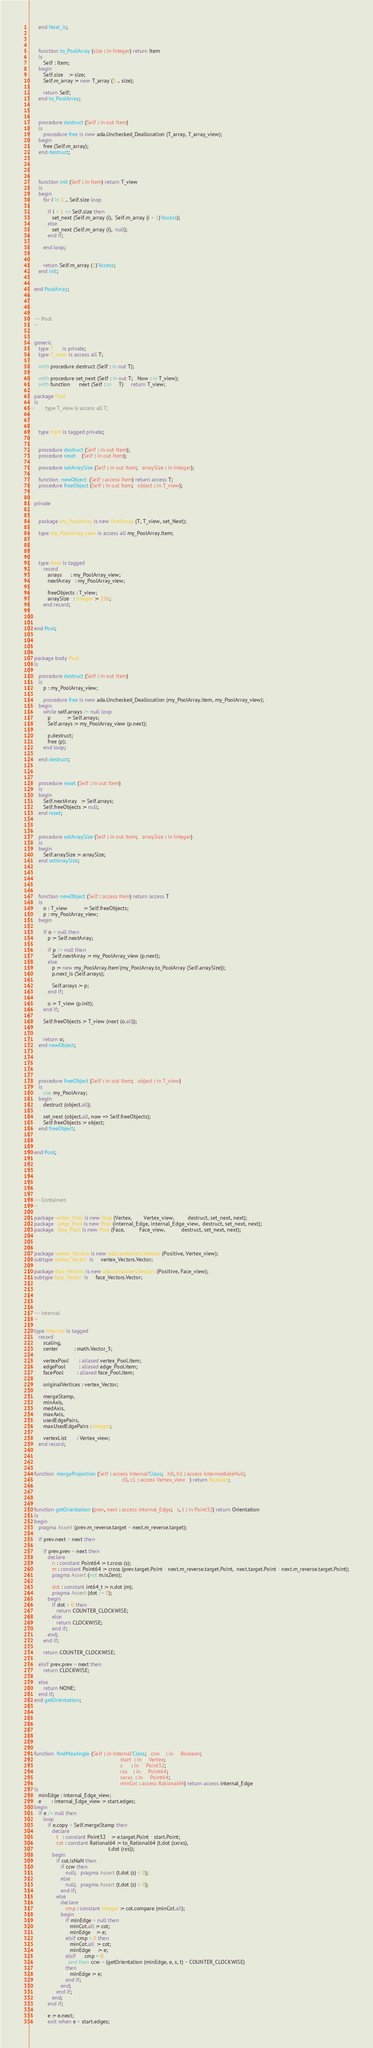Convert code to text. <code><loc_0><loc_0><loc_500><loc_500><_Ada_>      end Next_is;



      function to_PoolArray (size : in Integer) return Item
      is
         Self : Item;
      begin
         Self.size    := size;
         Self.m_array := new T_array (1 .. size);

         return Self;
      end to_PoolArray;



      procedure destruct (Self : in out Item)
      is
         procedure free is new ada.Unchecked_Deallocation (T_array, T_array_view);
      begin
         free (Self.m_array);
      end destruct;




      function init (Self : in Item) return T_view
      is
      begin
         for i in 1 .. Self.size loop

            if i + 1 <= Self.size then
               set_next (Self.m_array (i),  Self.m_array (i + 1)'Access);
            else
               set_next (Self.m_array (i),  null);
            end if;

         end loop;


         return Self.m_array (1)'Access;
      end init;


   end PoolArray;




   --- Pool
   --


   generic
      type T      is private;
      type T_view is access all T;

      with procedure destruct (Self : in out T);

      with procedure set_next (Self : in out T;   Now : in T_view);
      with function      next (Self : in     T)     return T_view;

   package Pool
   is
--        type T_view is access all T;



      type Item is tagged private;


      procedure destruct (Self : in out Item);
      procedure reset    (Self : in out Item);

      procedure setArraySize (Self : in out Item;   arraySize : in Integer);

      function  newObject  (Self : access Item) return access T;
      procedure freeObject (Self : in out Item;   object : in T_view);


   private


      package my_PoolArray is new PoolArray (T, T_view, set_Next);

      type my_PoolArray_view is access all my_PoolArray.Item;




      type Item is tagged
         record
            arrays      : my_PoolArray_view;
            nextArray   : my_PoolArray_view;

            freeObjects : T_view;
            arraySize   : Integer := 256;
         end record;



   end Pool;




   package body Pool
   is

      procedure destruct (Self : in out Item)
      is
         p : my_PoolArray_view;

         procedure free is new ada.Unchecked_Deallocation (my_PoolArray.item, my_PoolArray_view);
      begin
         while self.arrays /= null loop
            p           := Self.arrays;
            Self.arrays := my_PoolArray_view (p.next);

            p.destruct;
            free (p);
         end loop;

      end destruct;



      procedure reset (Self : in out Item)
      is
      begin
         Self.nextArray   := Self.arrays;
         Self.freeObjects := null;
      end reset;



      procedure setArraySize (Self : in out Item;   arraySize : in Integer)
      is
      begin
         Self.arraySize := arraySize;
      end setArraySize;





      function newObject (Self : access Item) return access T
      is
         o : T_view           := Self.freeObjects;
         p : my_PoolArray_view;
      begin

         if o = null then
            p := Self.nextArray;

            if p /= null then
               Self.nextArray := my_PoolArray_view (p.next);
            else
               p := new my_PoolArray.Item'(my_PoolArray.to_PoolArray (Self.arraySize));
               p.next_is (Self.arrays);

               Self.arrays := p;
            end if;

            o := T_view (p.init);
         end if;

         Self.freeObjects := T_view (next (o.all));


         return o;
      end newObject;





      procedure freeObject (Self : in out Item;   object : in T_view)
      is
         use my_PoolArray;
      begin
         destruct (object.all);

         set_next (object.all, now => Self.freeObjects);
         Self.freeObjects := object;
      end freeObject;



   end Pool;







   --- Containers
   --

   package vertex_Pool is new Pool (Vertex,        Vertex_view,         destruct, set_next, next);
   package   edge_Pool is new Pool (internal_Edge, internal_Edge_view,  destruct, set_next, next);
   package   face_Pool is new Pool (Face,          Face_view,           destruct, set_next, next);



   package vertex_Vectors is new ada.containers.Vectors (Positive, Vertex_view);
   subtype vertex_Vector  is     vertex_Vectors.Vector;

   package face_Vectors is new ada.containers.Vectors (Positive, Face_view);
   subtype face_Vector  is     face_Vectors.Vector;





   --- Internal
   --

   type Internal is tagged
      record
         scaling,
         center           : math.Vector_3;

         vertexPool       : aliased vertex_Pool.item;
         edgePool         : aliased edge_Pool.item;
         facePool         : aliased face_Pool.item;

         originalVertices : vertex_Vector;

         mergeStamp,
         minAxis,
         medAxis,
         maxAxis,
         usedEdgePairs,
         maxUsedEdgePairs : Integer;

         vertexList       : Vertex_view;
      end record;




   function  mergeProjection (Self : access Internal'Class;   h0, h1 : access IntermediateHull;
                                                              c0, c1 : access Vertex_view   ) return Boolean;




   function getOrientation (prev, next : access internal_Edge;   s, t : in Point32) return Orientation
   is
   begin
      pragma Assert (prev.m_reverse.target = next.m_reverse.target);

      if prev.next = next then

         if prev.prev = next then
            declare
               n : constant Point64 := t.cross (s);
               m : constant Point64 := cross (prev.target.Point - next.m_reverse.target.Point,  next.target.Point - next.m_reverse.target.Point);
               pragma Assert (not m.isZero);

               dot : constant int64_t := n.dot (m);
               pragma Assert (dot /= 0);
            begin
               if dot > 0 then
                  return COUNTER_CLOCKWISE;
               else
                  return CLOCKWISE;
               end if;
            end;
         end if;

         return COUNTER_CLOCKWISE;

      elsif prev.prev = next then
         return CLOCKWISE;

      else
         return NONE;
      end if;
   end getOrientation;








   function  findMaxAngle (Self : in Internal'Class;   ccw    : in     Boolean;
                                                             start  : in     Vertex;
                                                             s      : in     Point32;
                                                             rxs    : in     Point64;
                                                             sxrxs  : in     Point64;
                                                             minCot : access Rational64) return access internal_Edge
   is
      minEdge : internal_Edge_view;
      e       : internal_Edge_view := start.edges;
   begin
      if e /= null then
         loop
            if e.copy > Self.mergeStamp then
               declare
                  t   : constant Point32    := e.target.Point - start.Point;
                  cot : constant Rational64 := to_Rational64 (t.dot (sxrxs),
                                                     t.dot (rxs));
               begin
                  if cot.isNaN then
                     if ccw then
                        null;   pragma Assert (t.dot (s) < 0);
                     else
                        null;   pragma Assert (t.dot (s) > 0);
                     end if;
                  else
                     declare
                        cmp : constant Integer := cot.compare (minCot.all);
                     begin
                        if minEdge = null then
                           minCot.all := cot;
                           minEdge    := e;
                        elsif cmp < 0 then
                           minCot.all  := cot;
                           minEdge     := e;
                        elsif      cmp = 0
                          and then ccw = (getOrientation (minEdge, e, s, t) = COUNTER_CLOCKWISE)
                        then
                           minEdge := e;
                        end if;
                     end;
                  end if;
               end;
            end if;

            e := e.next;
            exit when e = start.edges;</code> 